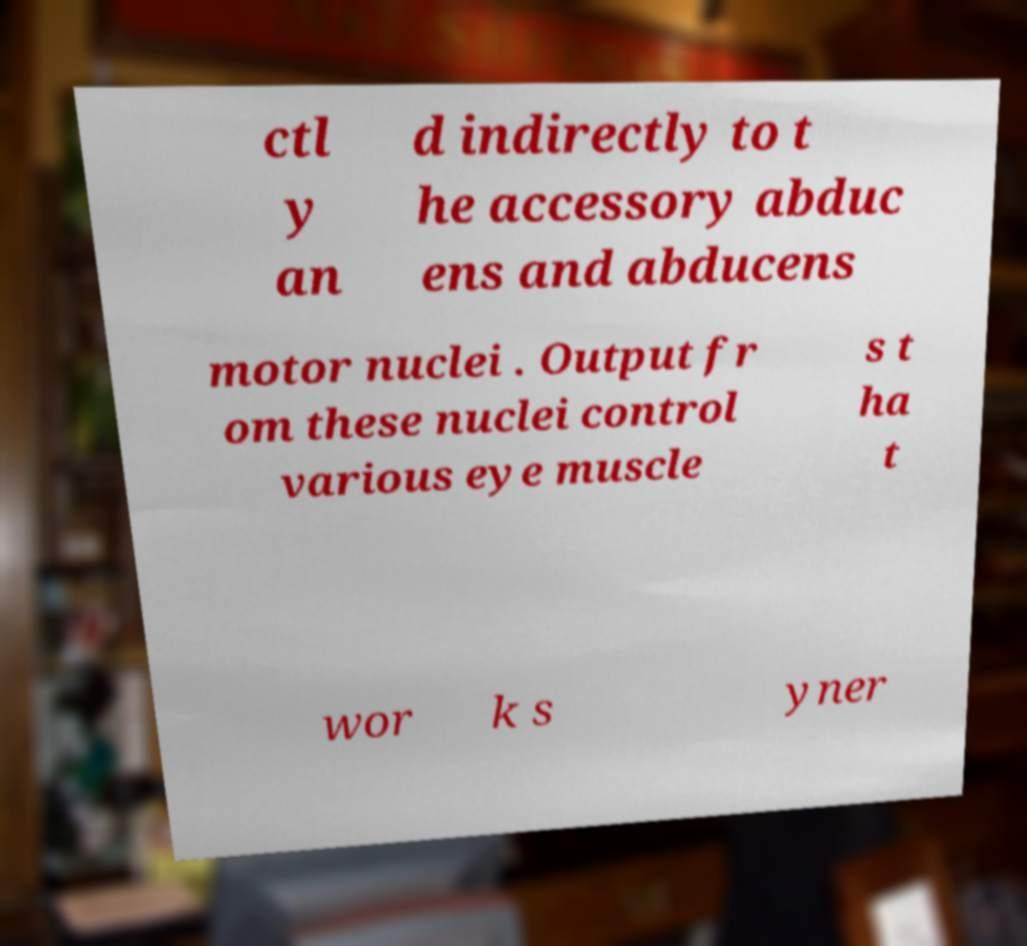What messages or text are displayed in this image? I need them in a readable, typed format. ctl y an d indirectly to t he accessory abduc ens and abducens motor nuclei . Output fr om these nuclei control various eye muscle s t ha t wor k s yner 